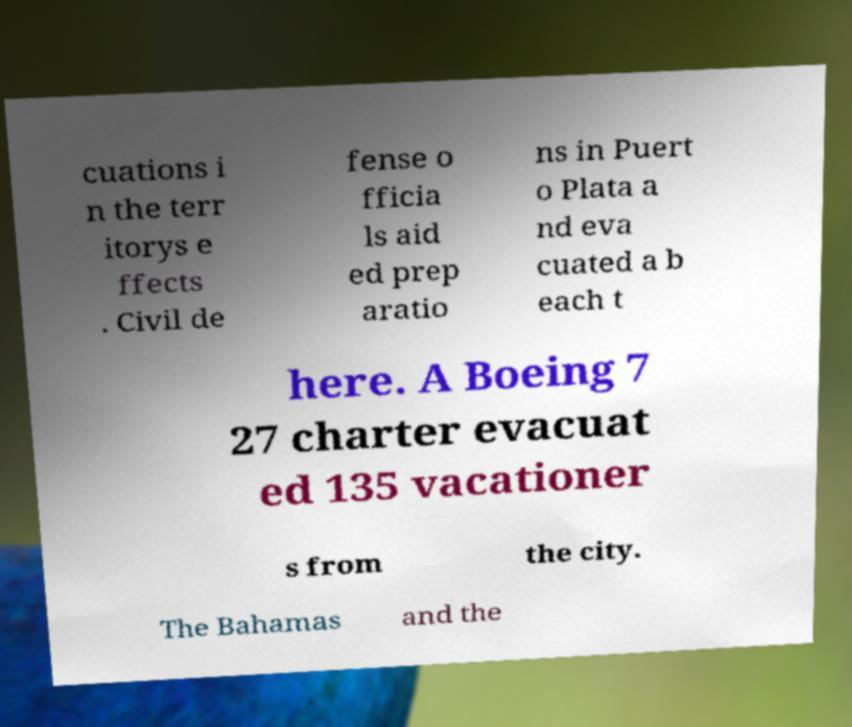Could you assist in decoding the text presented in this image and type it out clearly? cuations i n the terr itorys e ffects . Civil de fense o fficia ls aid ed prep aratio ns in Puert o Plata a nd eva cuated a b each t here. A Boeing 7 27 charter evacuat ed 135 vacationer s from the city. The Bahamas and the 